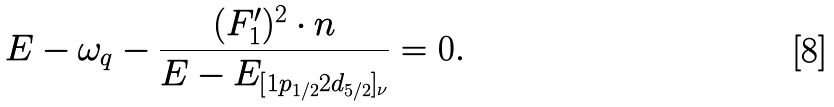Convert formula to latex. <formula><loc_0><loc_0><loc_500><loc_500>E - \omega _ { q } - \frac { ( F _ { 1 } ^ { \prime } ) ^ { 2 } \cdot n } { E - E _ { [ 1 p _ { 1 / 2 } 2 d _ { 5 / 2 } ] _ { \nu } } } = 0 .</formula> 